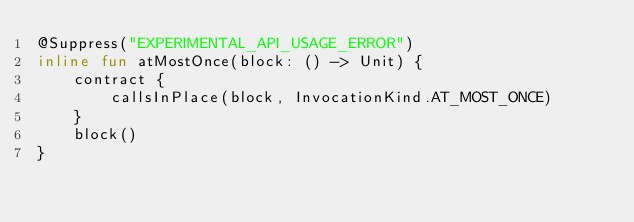<code> <loc_0><loc_0><loc_500><loc_500><_Kotlin_>@Suppress("EXPERIMENTAL_API_USAGE_ERROR")
inline fun atMostOnce(block: () -> Unit) {
    contract {
        callsInPlace(block, InvocationKind.AT_MOST_ONCE)
    }
    block()
}
</code> 